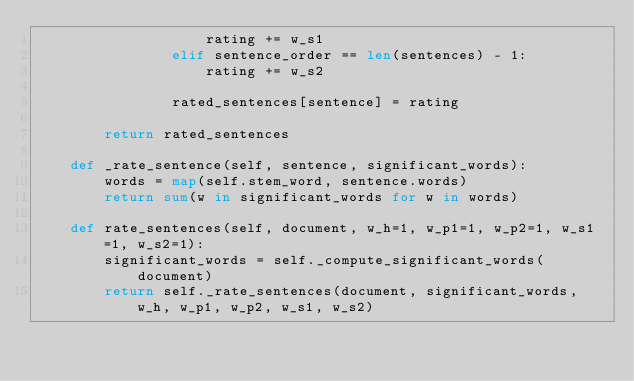Convert code to text. <code><loc_0><loc_0><loc_500><loc_500><_Python_>                    rating += w_s1
                elif sentence_order == len(sentences) - 1:
                    rating += w_s2

                rated_sentences[sentence] = rating

        return rated_sentences

    def _rate_sentence(self, sentence, significant_words):
        words = map(self.stem_word, sentence.words)
        return sum(w in significant_words for w in words)

    def rate_sentences(self, document, w_h=1, w_p1=1, w_p2=1, w_s1=1, w_s2=1):
        significant_words = self._compute_significant_words(document)
        return self._rate_sentences(document, significant_words, w_h, w_p1, w_p2, w_s1, w_s2)
</code> 